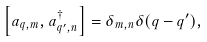<formula> <loc_0><loc_0><loc_500><loc_500>\left [ a _ { { q } , m } , a _ { { q ^ { \prime } } , n } ^ { \dagger } \right ] = \delta _ { m , n } \delta ( { q } - { q ^ { \prime } } ) ,</formula> 